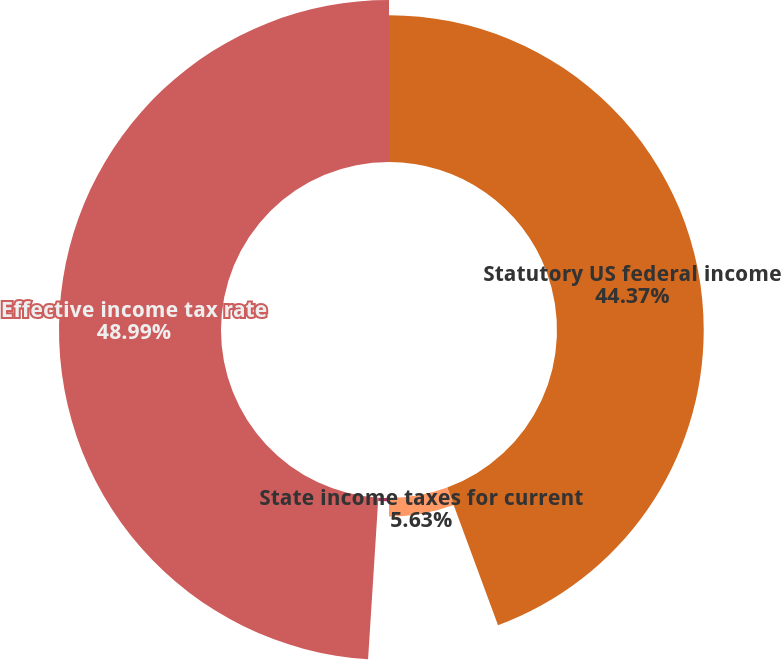Convert chart. <chart><loc_0><loc_0><loc_500><loc_500><pie_chart><fcel>Statutory US federal income<fcel>State income taxes for current<fcel>Other items<fcel>Effective income tax rate<nl><fcel>44.37%<fcel>5.63%<fcel>1.01%<fcel>48.99%<nl></chart> 